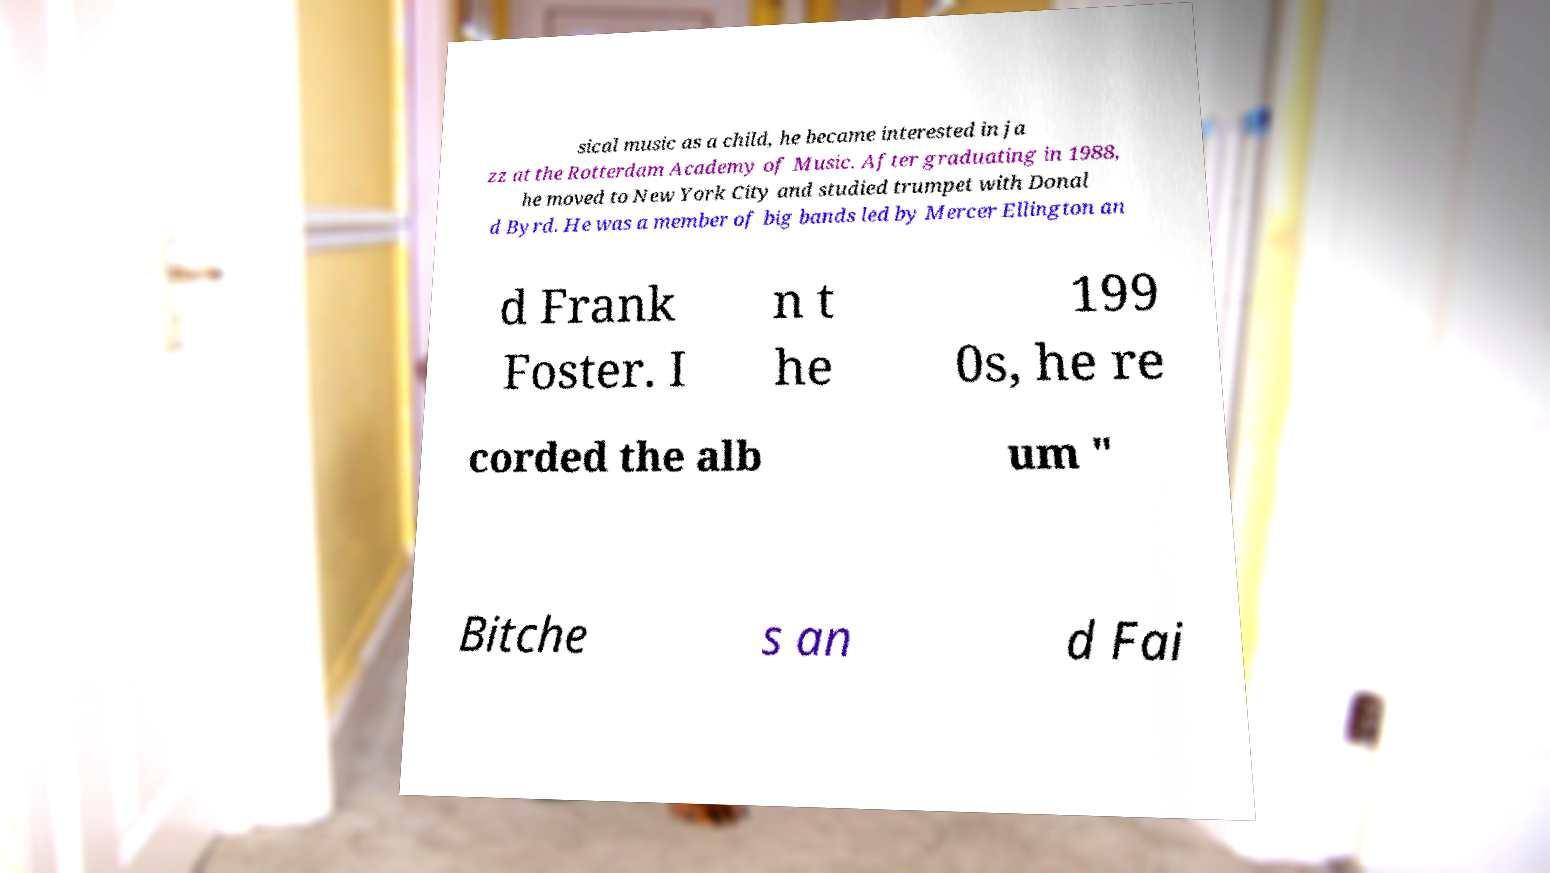Can you read and provide the text displayed in the image?This photo seems to have some interesting text. Can you extract and type it out for me? sical music as a child, he became interested in ja zz at the Rotterdam Academy of Music. After graduating in 1988, he moved to New York City and studied trumpet with Donal d Byrd. He was a member of big bands led by Mercer Ellington an d Frank Foster. I n t he 199 0s, he re corded the alb um " Bitche s an d Fai 